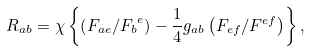Convert formula to latex. <formula><loc_0><loc_0><loc_500><loc_500>R _ { a b } = \chi \left \{ \left ( F _ { a e } / { F _ { b } } ^ { e } \right ) - \frac { 1 } { 4 } g _ { a b } \left ( F _ { e f } / F ^ { e f } \right ) \right \} ,</formula> 